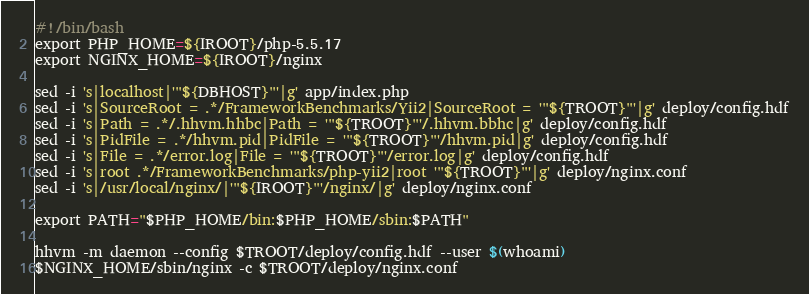Convert code to text. <code><loc_0><loc_0><loc_500><loc_500><_Bash_>#!/bin/bash
export PHP_HOME=${IROOT}/php-5.5.17
export NGINX_HOME=${IROOT}/nginx

sed -i 's|localhost|'"${DBHOST}"'|g' app/index.php
sed -i 's|SourceRoot = .*/FrameworkBenchmarks/Yii2|SourceRoot = '"${TROOT}"'|g' deploy/config.hdf
sed -i 's|Path = .*/.hhvm.hhbc|Path = '"${TROOT}"'/.hhvm.bbhc|g' deploy/config.hdf
sed -i 's|PidFile = .*/hhvm.pid|PidFile = '"${TROOT}"'/hhvm.pid|g' deploy/config.hdf
sed -i 's|File = .*/error.log|File = '"${TROOT}"'/error.log|g' deploy/config.hdf
sed -i 's|root .*/FrameworkBenchmarks/php-yii2|root '"${TROOT}"'|g' deploy/nginx.conf
sed -i 's|/usr/local/nginx/|'"${IROOT}"'/nginx/|g' deploy/nginx.conf

export PATH="$PHP_HOME/bin:$PHP_HOME/sbin:$PATH"

hhvm -m daemon --config $TROOT/deploy/config.hdf --user $(whoami)
$NGINX_HOME/sbin/nginx -c $TROOT/deploy/nginx.conf
</code> 